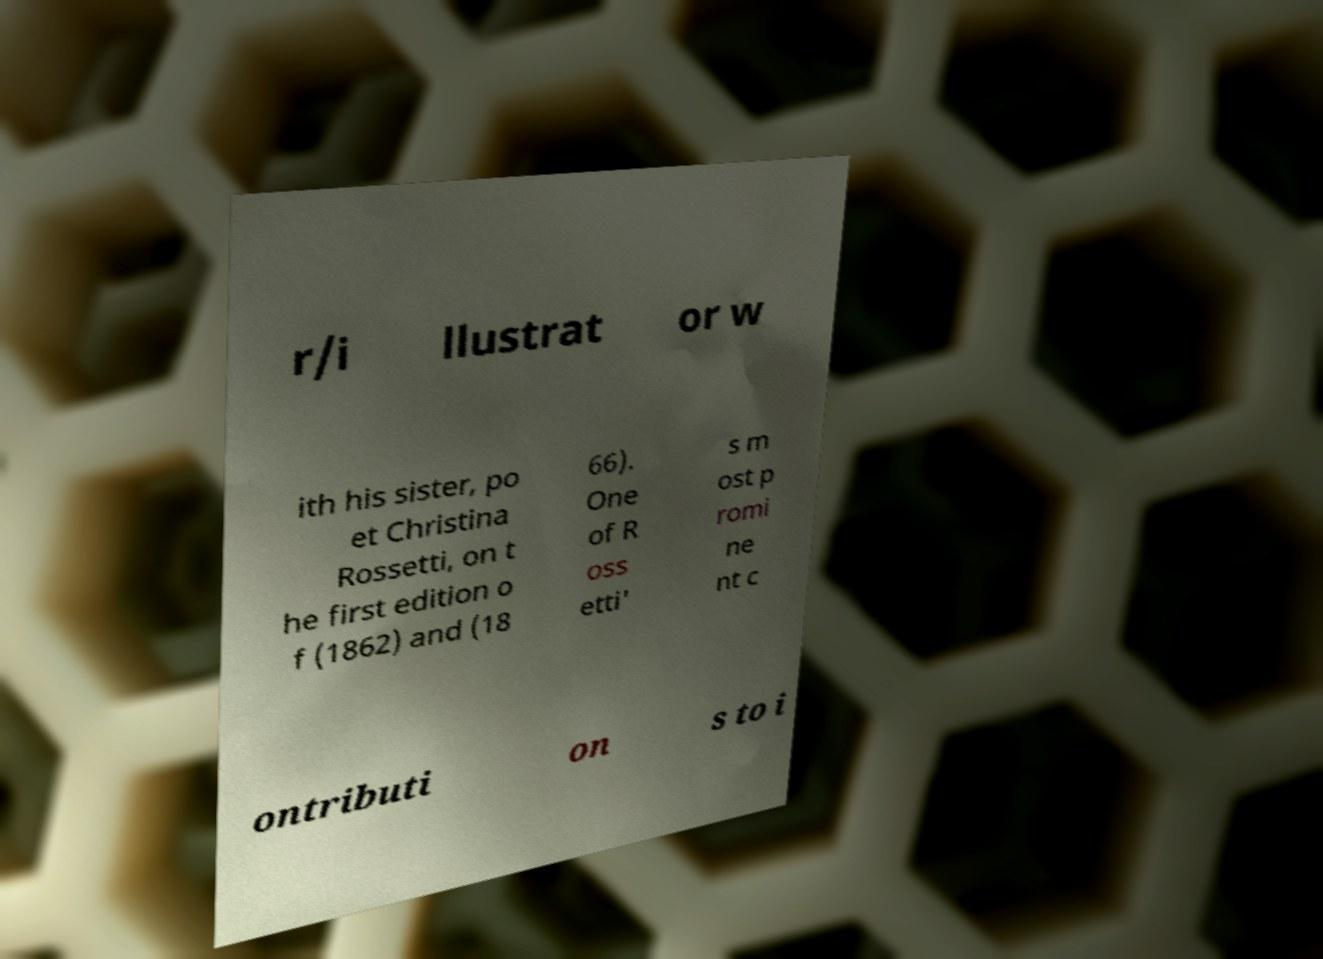Can you accurately transcribe the text from the provided image for me? r/i llustrat or w ith his sister, po et Christina Rossetti, on t he first edition o f (1862) and (18 66). One of R oss etti' s m ost p romi ne nt c ontributi on s to i 